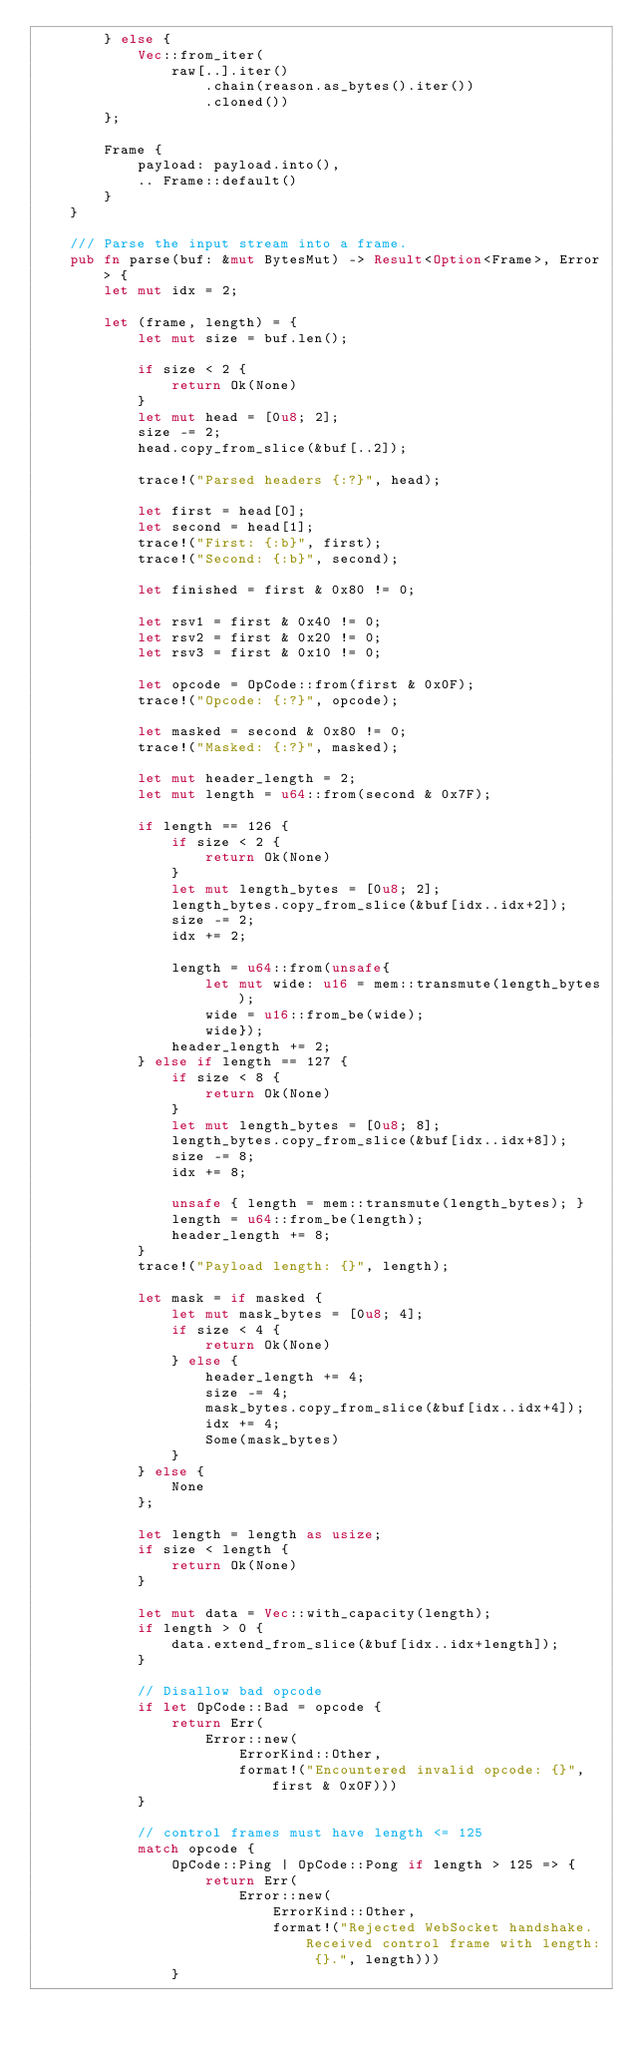<code> <loc_0><loc_0><loc_500><loc_500><_Rust_>        } else {
            Vec::from_iter(
                raw[..].iter()
                    .chain(reason.as_bytes().iter())
                    .cloned())
        };

        Frame {
            payload: payload.into(),
            .. Frame::default()
        }
    }

    /// Parse the input stream into a frame.
    pub fn parse(buf: &mut BytesMut) -> Result<Option<Frame>, Error> {
        let mut idx = 2;

        let (frame, length) = {
            let mut size = buf.len();

            if size < 2 {
                return Ok(None)
            }
            let mut head = [0u8; 2];
            size -= 2;
            head.copy_from_slice(&buf[..2]);

            trace!("Parsed headers {:?}", head);

            let first = head[0];
            let second = head[1];
            trace!("First: {:b}", first);
            trace!("Second: {:b}", second);

            let finished = first & 0x80 != 0;

            let rsv1 = first & 0x40 != 0;
            let rsv2 = first & 0x20 != 0;
            let rsv3 = first & 0x10 != 0;

            let opcode = OpCode::from(first & 0x0F);
            trace!("Opcode: {:?}", opcode);

            let masked = second & 0x80 != 0;
            trace!("Masked: {:?}", masked);

            let mut header_length = 2;
            let mut length = u64::from(second & 0x7F);

            if length == 126 {
                if size < 2 {
                    return Ok(None)
                }
                let mut length_bytes = [0u8; 2];
                length_bytes.copy_from_slice(&buf[idx..idx+2]);
                size -= 2;
                idx += 2;

                length = u64::from(unsafe{
                    let mut wide: u16 = mem::transmute(length_bytes);
                    wide = u16::from_be(wide);
                    wide});
                header_length += 2;
            } else if length == 127 {
                if size < 8 {
                    return Ok(None)
                }
                let mut length_bytes = [0u8; 8];
                length_bytes.copy_from_slice(&buf[idx..idx+8]);
                size -= 8;
                idx += 8;

                unsafe { length = mem::transmute(length_bytes); }
                length = u64::from_be(length);
                header_length += 8;
            }
            trace!("Payload length: {}", length);

            let mask = if masked {
                let mut mask_bytes = [0u8; 4];
                if size < 4 {
                    return Ok(None)
                } else {
                    header_length += 4;
                    size -= 4;
                    mask_bytes.copy_from_slice(&buf[idx..idx+4]);
                    idx += 4;
                    Some(mask_bytes)
                }
            } else {
                None
            };

            let length = length as usize;
            if size < length {
                return Ok(None)
            }

            let mut data = Vec::with_capacity(length);
            if length > 0 {
                data.extend_from_slice(&buf[idx..idx+length]);
            }

            // Disallow bad opcode
            if let OpCode::Bad = opcode {
                return Err(
                    Error::new(
                        ErrorKind::Other,
                        format!("Encountered invalid opcode: {}", first & 0x0F)))
            }

            // control frames must have length <= 125
            match opcode {
                OpCode::Ping | OpCode::Pong if length > 125 => {
                    return Err(
                        Error::new(
                            ErrorKind::Other,
                            format!("Rejected WebSocket handshake.Received control frame with length: {}.", length)))
                }</code> 